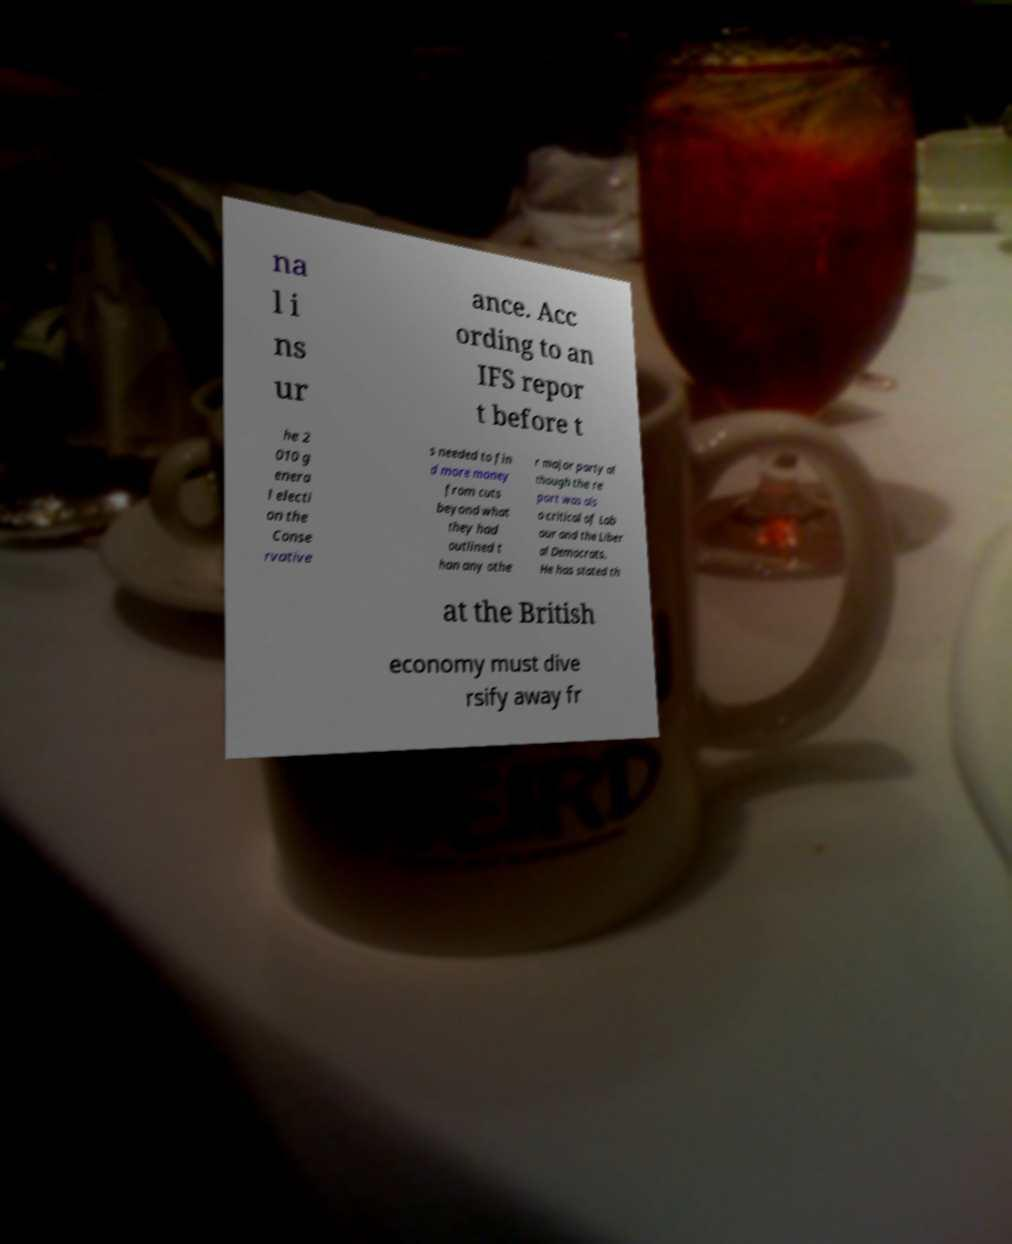Please read and relay the text visible in this image. What does it say? na l i ns ur ance. Acc ording to an IFS repor t before t he 2 010 g enera l electi on the Conse rvative s needed to fin d more money from cuts beyond what they had outlined t han any othe r major party al though the re port was als o critical of Lab our and the Liber al Democrats. He has stated th at the British economy must dive rsify away fr 